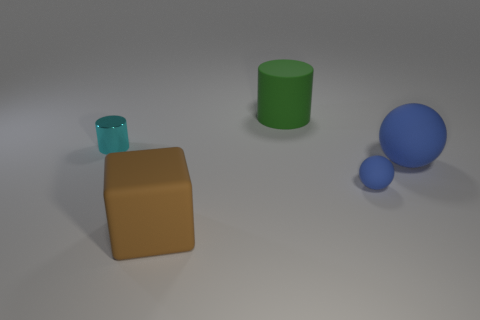What materials do the objects in the image seem to be made of? The objects appear to have matte surfaces, suggesting they could be made from materials such as plastic, ceramic, or painted metal, which often have non-reflective finishes. 